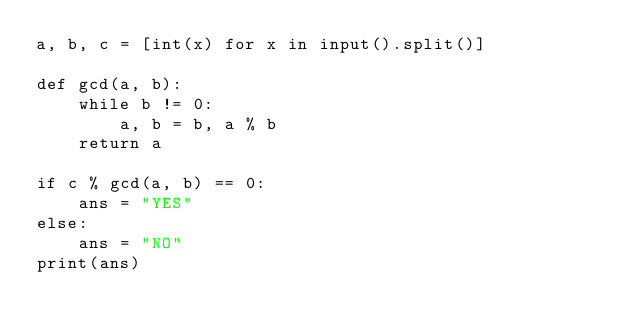<code> <loc_0><loc_0><loc_500><loc_500><_Python_>a, b, c = [int(x) for x in input().split()]

def gcd(a, b):
    while b != 0:
        a, b = b, a % b
    return a 

if c % gcd(a, b) == 0:
    ans = "YES"
else:
    ans = "NO"
print(ans)

</code> 